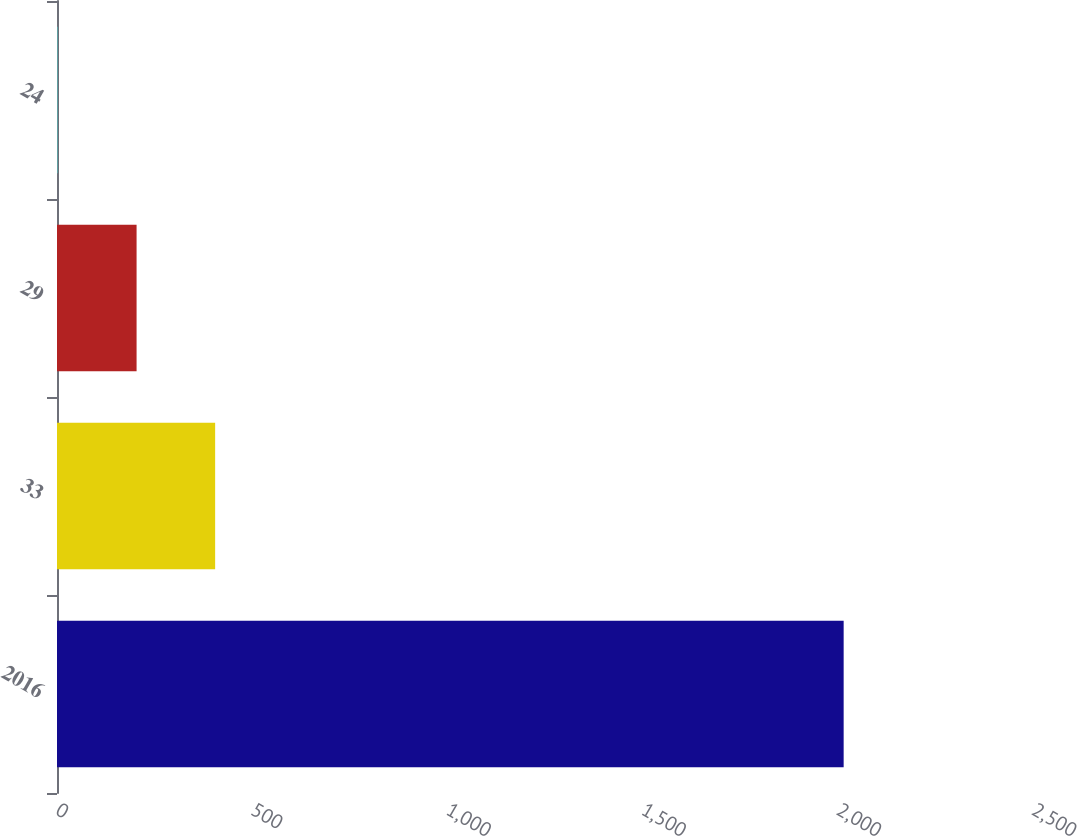Convert chart to OTSL. <chart><loc_0><loc_0><loc_500><loc_500><bar_chart><fcel>2016<fcel>33<fcel>29<fcel>24<nl><fcel>2015<fcel>405.08<fcel>203.84<fcel>2.6<nl></chart> 